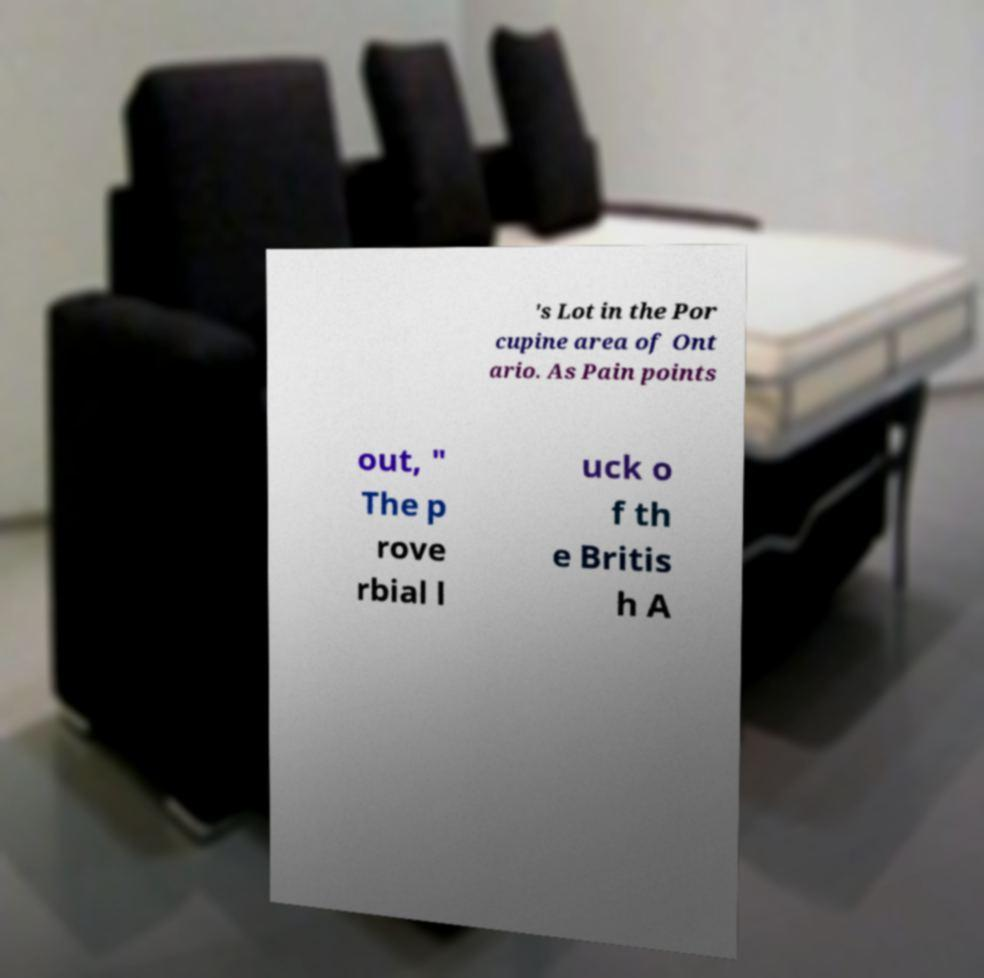For documentation purposes, I need the text within this image transcribed. Could you provide that? 's Lot in the Por cupine area of Ont ario. As Pain points out, " The p rove rbial l uck o f th e Britis h A 